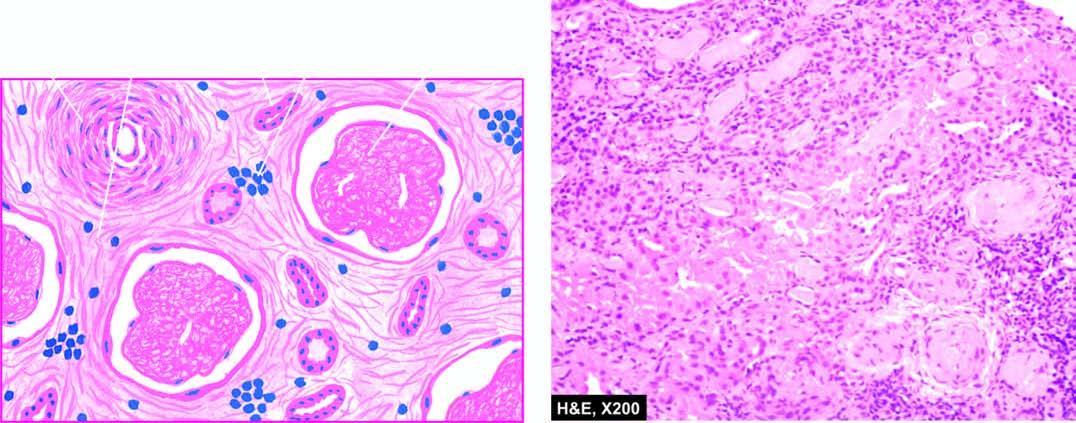what are acellular and completely hyalinised?
Answer the question using a single word or phrase. Glomerular tufts 